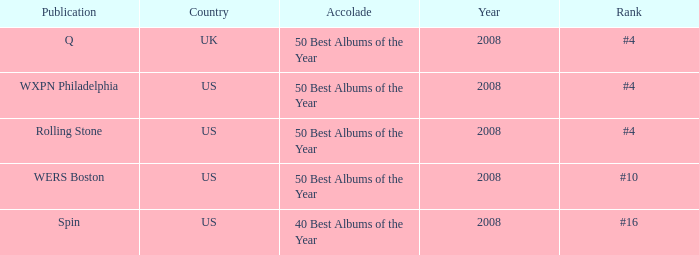Which rank's country is the US when the accolade is 40 best albums of the year? #16. 